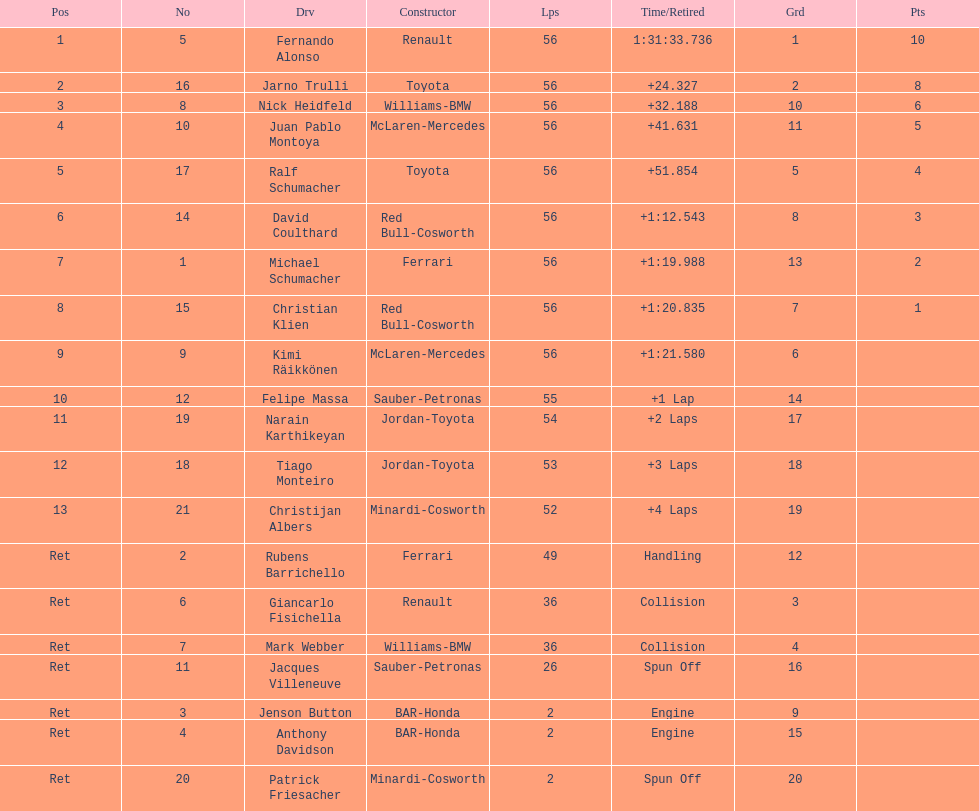How many drivers ended the race early because of engine problems? 2. 